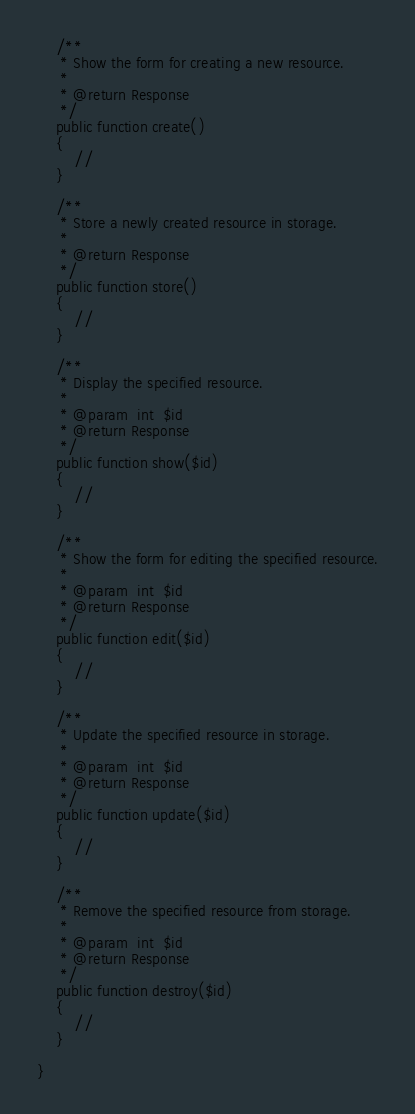Convert code to text. <code><loc_0><loc_0><loc_500><loc_500><_PHP_>
	/**
	 * Show the form for creating a new resource.
	 *
	 * @return Response
	 */
	public function create()
	{
		//
	}

	/**
	 * Store a newly created resource in storage.
	 *
	 * @return Response
	 */
	public function store()
	{
		//
	}

	/**
	 * Display the specified resource.
	 *
	 * @param  int  $id
	 * @return Response
	 */
	public function show($id)
	{
		//
	}

	/**
	 * Show the form for editing the specified resource.
	 *
	 * @param  int  $id
	 * @return Response
	 */
	public function edit($id)
	{
		//
	}

	/**
	 * Update the specified resource in storage.
	 *
	 * @param  int  $id
	 * @return Response
	 */
	public function update($id)
	{
		//
	}

	/**
	 * Remove the specified resource from storage.
	 *
	 * @param  int  $id
	 * @return Response
	 */
	public function destroy($id)
	{
		//
	}

}


</code> 